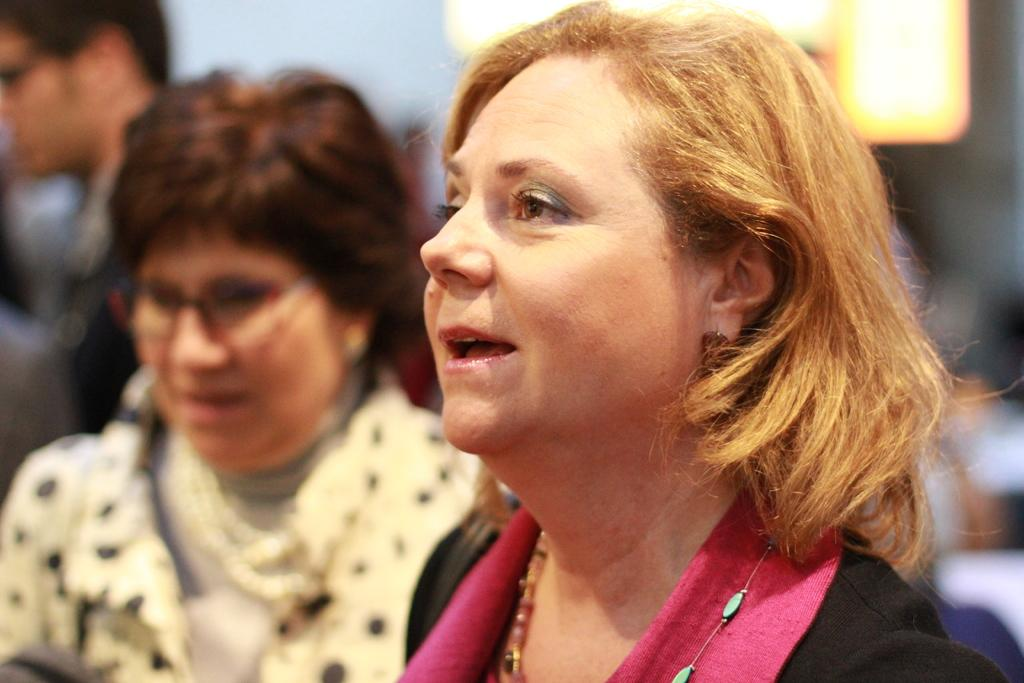Who or what is present in the image? There are people in the image. What are the people wearing? The people are wearing different color dresses. Can you describe the background of the image? The background of the image is blurred. What type of crate is being used by the people in the image? There is no crate present in the image; it features people wearing different color dresses with a blurred background. 